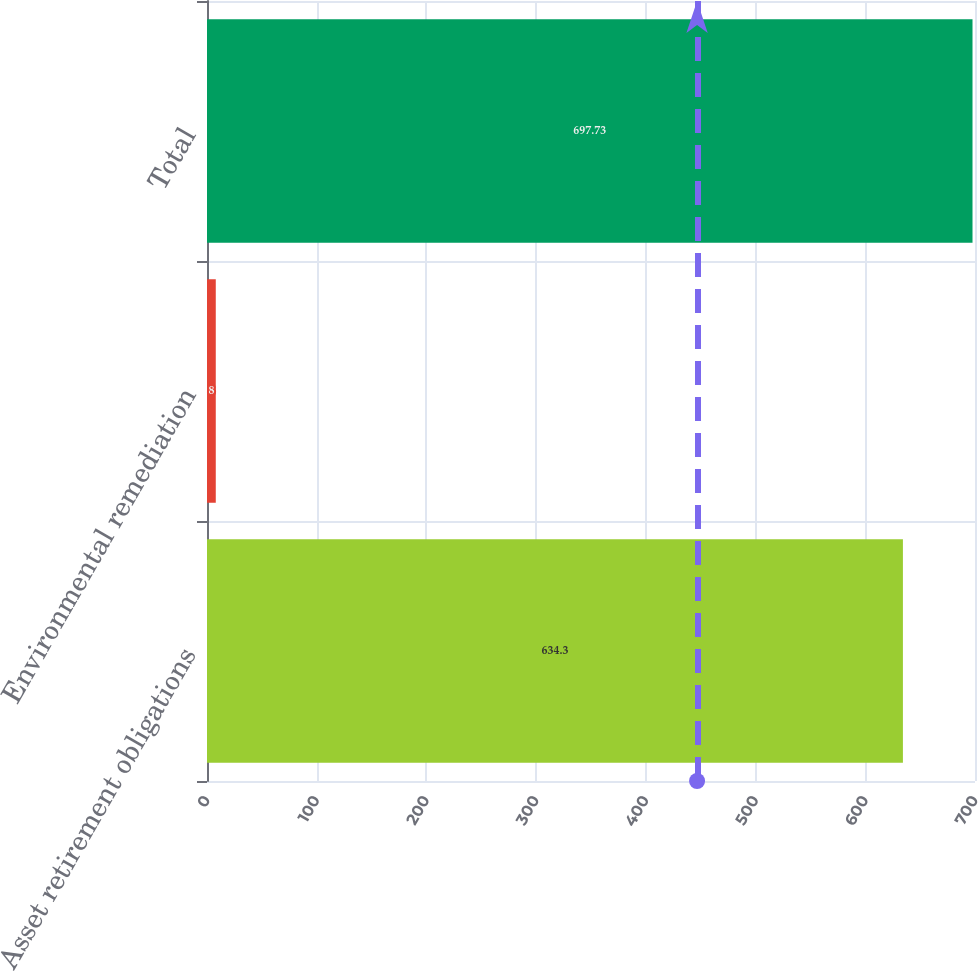<chart> <loc_0><loc_0><loc_500><loc_500><bar_chart><fcel>Asset retirement obligations<fcel>Environmental remediation<fcel>Total<nl><fcel>634.3<fcel>8<fcel>697.73<nl></chart> 